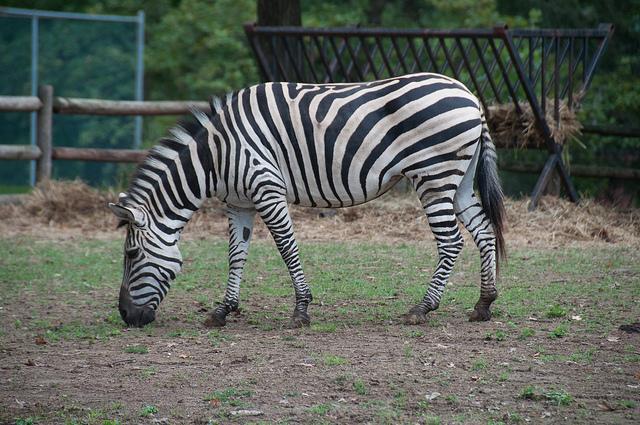How many zebras do you see?
Give a very brief answer. 1. How many different types of animals are there?
Give a very brief answer. 1. How many zebras are there?
Give a very brief answer. 1. How many animals are present?
Give a very brief answer. 1. How many animals are shown?
Give a very brief answer. 1. How many of these animals are there?
Give a very brief answer. 1. How many zebras in the photo?
Give a very brief answer. 1. How many people in the photo are wearing red shoes?
Give a very brief answer. 0. 